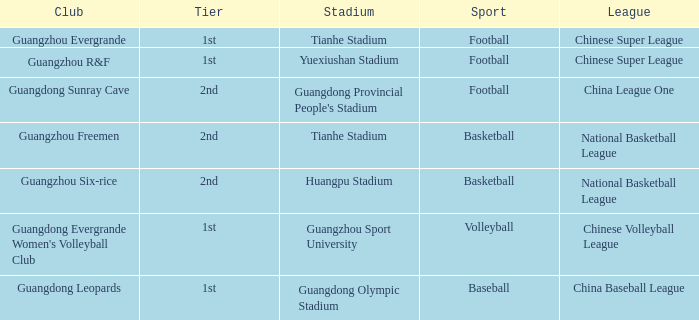Can you parse all the data within this table? {'header': ['Club', 'Tier', 'Stadium', 'Sport', 'League'], 'rows': [['Guangzhou Evergrande', '1st', 'Tianhe Stadium', 'Football', 'Chinese Super League'], ['Guangzhou R&F', '1st', 'Yuexiushan Stadium', 'Football', 'Chinese Super League'], ['Guangdong Sunray Cave', '2nd', "Guangdong Provincial People's Stadium", 'Football', 'China League One'], ['Guangzhou Freemen', '2nd', 'Tianhe Stadium', 'Basketball', 'National Basketball League'], ['Guangzhou Six-rice', '2nd', 'Huangpu Stadium', 'Basketball', 'National Basketball League'], ["Guangdong Evergrande Women's Volleyball Club", '1st', 'Guangzhou Sport University', 'Volleyball', 'Chinese Volleyball League'], ['Guangdong Leopards', '1st', 'Guangdong Olympic Stadium', 'Baseball', 'China Baseball League']]} Which tier is for football at Tianhe Stadium? 1st. 